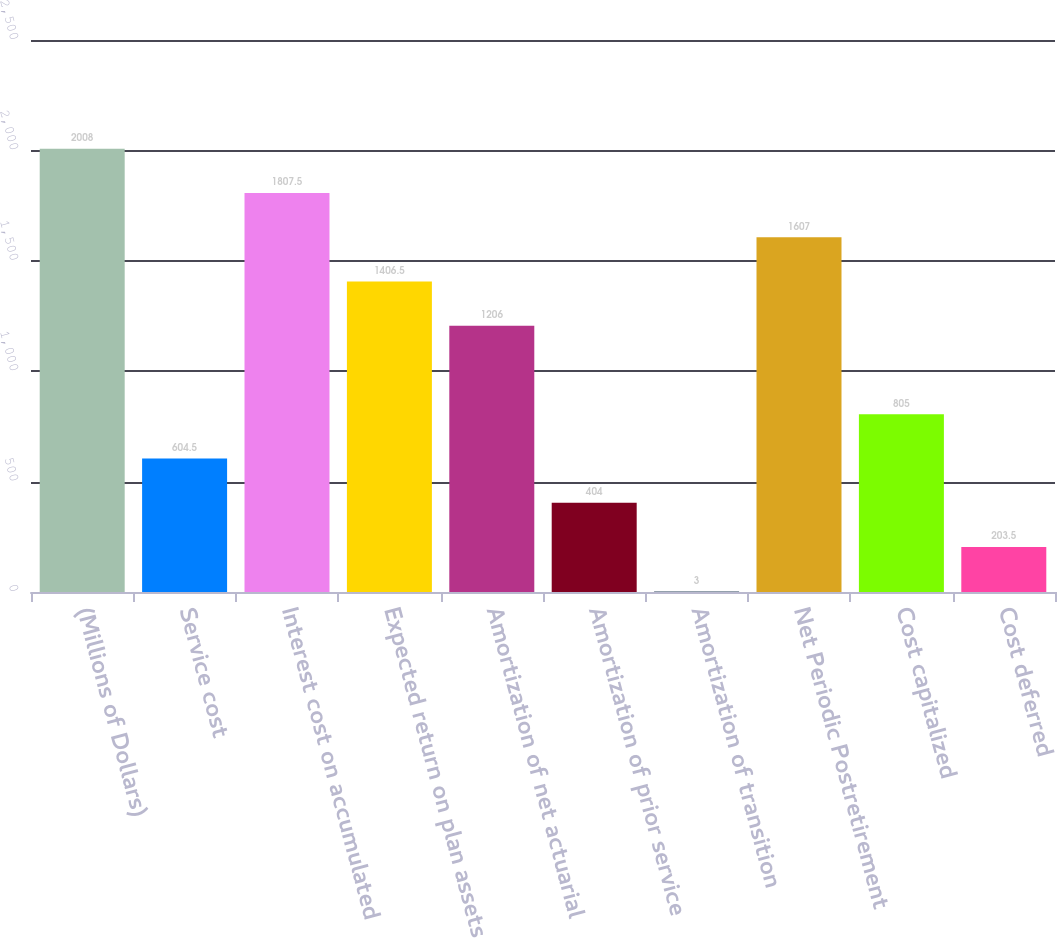Convert chart to OTSL. <chart><loc_0><loc_0><loc_500><loc_500><bar_chart><fcel>(Millions of Dollars)<fcel>Service cost<fcel>Interest cost on accumulated<fcel>Expected return on plan assets<fcel>Amortization of net actuarial<fcel>Amortization of prior service<fcel>Amortization of transition<fcel>Net Periodic Postretirement<fcel>Cost capitalized<fcel>Cost deferred<nl><fcel>2008<fcel>604.5<fcel>1807.5<fcel>1406.5<fcel>1206<fcel>404<fcel>3<fcel>1607<fcel>805<fcel>203.5<nl></chart> 